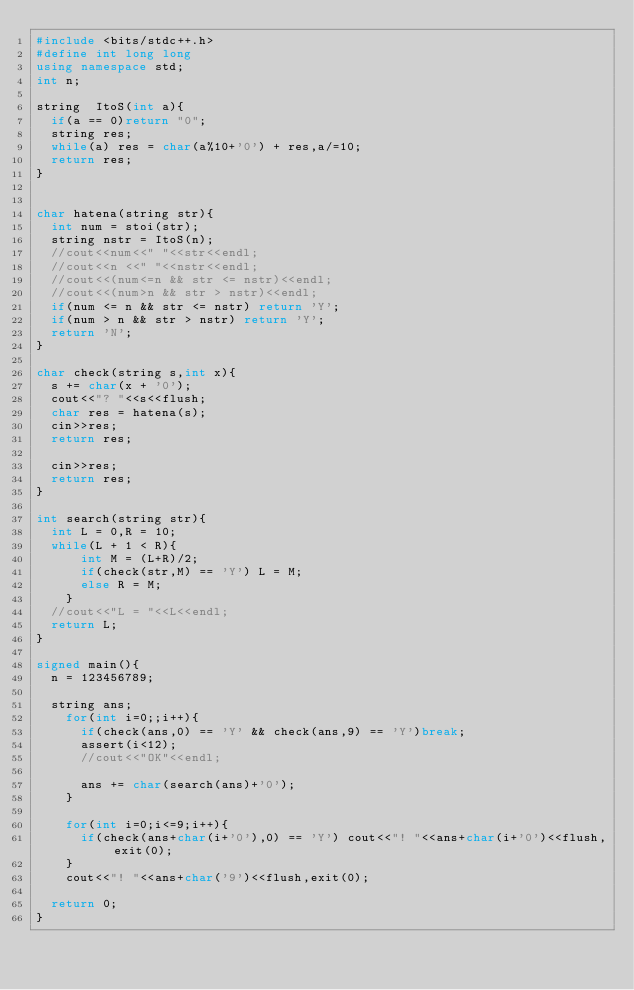Convert code to text. <code><loc_0><loc_0><loc_500><loc_500><_C++_>#include <bits/stdc++.h>
#define int long long
using namespace std;
int n;

string  ItoS(int a){
  if(a == 0)return "0";
  string res;
  while(a) res = char(a%10+'0') + res,a/=10;
  return res;
}


char hatena(string str){
  int num = stoi(str);
  string nstr = ItoS(n);
  //cout<<num<<" "<<str<<endl;
  //cout<<n <<" "<<nstr<<endl;
  //cout<<(num<=n && str <= nstr)<<endl;
  //cout<<(num>n && str > nstr)<<endl;
  if(num <= n && str <= nstr) return 'Y';
  if(num > n && str > nstr) return 'Y';
  return 'N';
}

char check(string s,int x){
  s += char(x + '0');
  cout<<"? "<<s<<flush;
  char res = hatena(s);
  cin>>res;
  return res;
    
  cin>>res;
  return res;
}

int search(string str){
  int L = 0,R = 10;
  while(L + 1 < R){
      int M = (L+R)/2;
      if(check(str,M) == 'Y') L = M;
      else R = M;
    }
  //cout<<"L = "<<L<<endl;
  return L;
}

signed main(){
  n = 123456789;

  string ans;  
    for(int i=0;;i++){
      if(check(ans,0) == 'Y' && check(ans,9) == 'Y')break;
      assert(i<12);
      //cout<<"OK"<<endl;
      
      ans += char(search(ans)+'0');
    }

    for(int i=0;i<=9;i++){
      if(check(ans+char(i+'0'),0) == 'Y') cout<<"! "<<ans+char(i+'0')<<flush,exit(0);
    }
    cout<<"! "<<ans+char('9')<<flush,exit(0);
    
  return 0;
}
</code> 